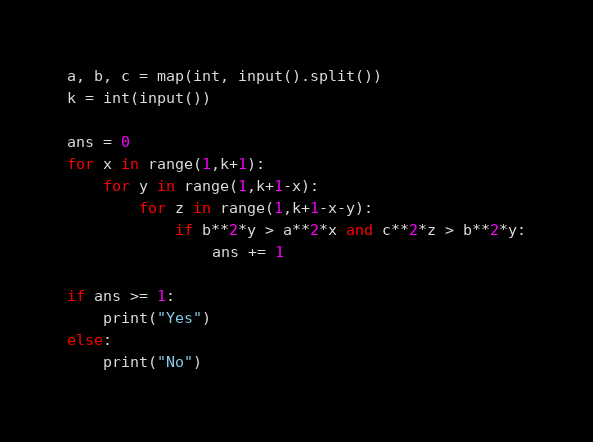Convert code to text. <code><loc_0><loc_0><loc_500><loc_500><_Python_>a, b, c = map(int, input().split())
k = int(input())

ans = 0
for x in range(1,k+1):
    for y in range(1,k+1-x):
        for z in range(1,k+1-x-y):
            if b**2*y > a**2*x and c**2*z > b**2*y:
                ans += 1

if ans >= 1:
    print("Yes")
else:
    print("No")
</code> 